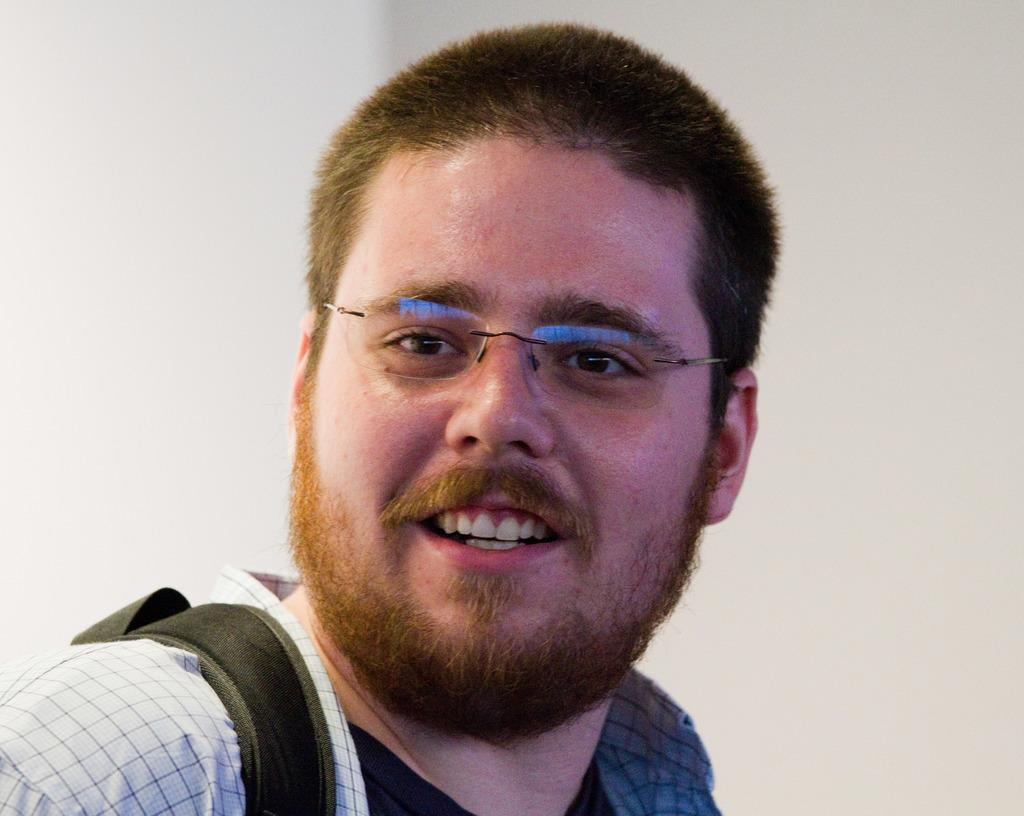What is the main subject of the image? There is a person in the image. What can be observed about the person's appearance? The person is wearing spectacles. What is the person's facial expression? The person is smiling. What is the color of the background in the image? The background of the image is white in color. What type of beef can be seen hanging from the person's spectacles in the image? There is no beef present in the image, and the person's spectacles are not holding any items. How many nails are visible on the person's face in the image? There are no nails visible on the person's face in the image. 